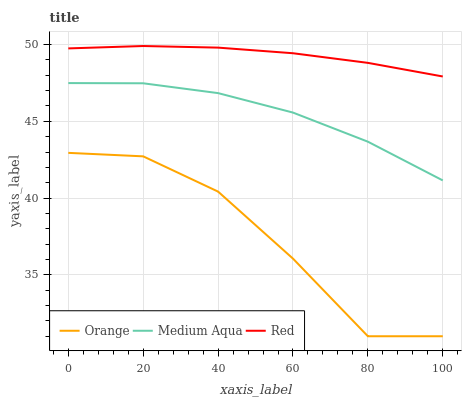Does Orange have the minimum area under the curve?
Answer yes or no. Yes. Does Red have the maximum area under the curve?
Answer yes or no. Yes. Does Medium Aqua have the minimum area under the curve?
Answer yes or no. No. Does Medium Aqua have the maximum area under the curve?
Answer yes or no. No. Is Red the smoothest?
Answer yes or no. Yes. Is Orange the roughest?
Answer yes or no. Yes. Is Medium Aqua the smoothest?
Answer yes or no. No. Is Medium Aqua the roughest?
Answer yes or no. No. Does Orange have the lowest value?
Answer yes or no. Yes. Does Medium Aqua have the lowest value?
Answer yes or no. No. Does Red have the highest value?
Answer yes or no. Yes. Does Medium Aqua have the highest value?
Answer yes or no. No. Is Medium Aqua less than Red?
Answer yes or no. Yes. Is Red greater than Medium Aqua?
Answer yes or no. Yes. Does Medium Aqua intersect Red?
Answer yes or no. No. 